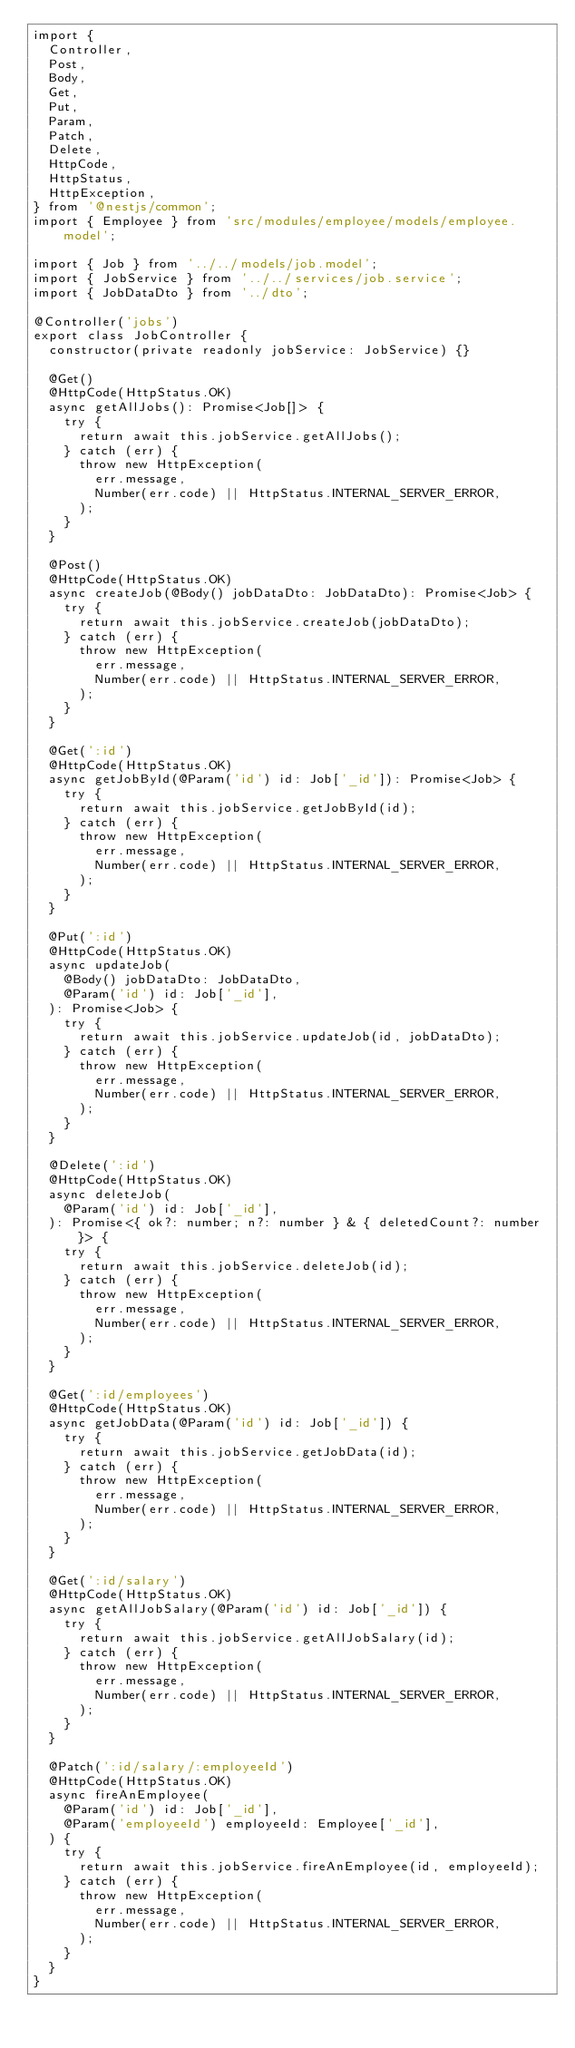Convert code to text. <code><loc_0><loc_0><loc_500><loc_500><_TypeScript_>import {
  Controller,
  Post,
  Body,
  Get,
  Put,
  Param,
  Patch,
  Delete,
  HttpCode,
  HttpStatus,
  HttpException,
} from '@nestjs/common';
import { Employee } from 'src/modules/employee/models/employee.model';

import { Job } from '../../models/job.model';
import { JobService } from '../../services/job.service';
import { JobDataDto } from '../dto';

@Controller('jobs')
export class JobController {
  constructor(private readonly jobService: JobService) {}

  @Get()
  @HttpCode(HttpStatus.OK)
  async getAllJobs(): Promise<Job[]> {
    try {
      return await this.jobService.getAllJobs();
    } catch (err) {
      throw new HttpException(
        err.message,
        Number(err.code) || HttpStatus.INTERNAL_SERVER_ERROR,
      );
    }
  }

  @Post()
  @HttpCode(HttpStatus.OK)
  async createJob(@Body() jobDataDto: JobDataDto): Promise<Job> {
    try {
      return await this.jobService.createJob(jobDataDto);
    } catch (err) {
      throw new HttpException(
        err.message,
        Number(err.code) || HttpStatus.INTERNAL_SERVER_ERROR,
      );
    }
  }

  @Get(':id')
  @HttpCode(HttpStatus.OK)
  async getJobById(@Param('id') id: Job['_id']): Promise<Job> {
    try {
      return await this.jobService.getJobById(id);
    } catch (err) {
      throw new HttpException(
        err.message,
        Number(err.code) || HttpStatus.INTERNAL_SERVER_ERROR,
      );
    }
  }

  @Put(':id')
  @HttpCode(HttpStatus.OK)
  async updateJob(
    @Body() jobDataDto: JobDataDto,
    @Param('id') id: Job['_id'],
  ): Promise<Job> {
    try {
      return await this.jobService.updateJob(id, jobDataDto);
    } catch (err) {
      throw new HttpException(
        err.message,
        Number(err.code) || HttpStatus.INTERNAL_SERVER_ERROR,
      );
    }
  }

  @Delete(':id')
  @HttpCode(HttpStatus.OK)
  async deleteJob(
    @Param('id') id: Job['_id'],
  ): Promise<{ ok?: number; n?: number } & { deletedCount?: number }> {
    try {
      return await this.jobService.deleteJob(id);
    } catch (err) {
      throw new HttpException(
        err.message,
        Number(err.code) || HttpStatus.INTERNAL_SERVER_ERROR,
      );
    }
  }

  @Get(':id/employees')
  @HttpCode(HttpStatus.OK)
  async getJobData(@Param('id') id: Job['_id']) {
    try {
      return await this.jobService.getJobData(id);
    } catch (err) {
      throw new HttpException(
        err.message,
        Number(err.code) || HttpStatus.INTERNAL_SERVER_ERROR,
      );
    }
  }

  @Get(':id/salary')
  @HttpCode(HttpStatus.OK)
  async getAllJobSalary(@Param('id') id: Job['_id']) {
    try {
      return await this.jobService.getAllJobSalary(id);
    } catch (err) {
      throw new HttpException(
        err.message,
        Number(err.code) || HttpStatus.INTERNAL_SERVER_ERROR,
      );
    }
  }

  @Patch(':id/salary/:employeeId')
  @HttpCode(HttpStatus.OK)
  async fireAnEmployee(
    @Param('id') id: Job['_id'],
    @Param('employeeId') employeeId: Employee['_id'],
  ) {
    try {
      return await this.jobService.fireAnEmployee(id, employeeId);
    } catch (err) {
      throw new HttpException(
        err.message,
        Number(err.code) || HttpStatus.INTERNAL_SERVER_ERROR,
      );
    }
  }
}
</code> 